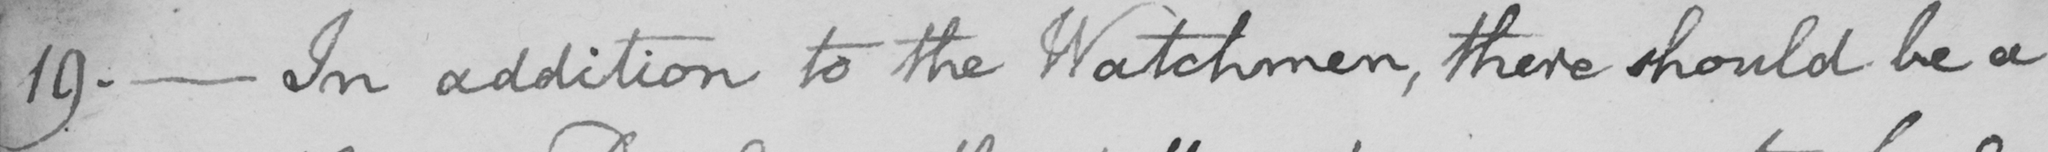What text is written in this handwritten line? 19 .  _  In addition to the Watchmen , there should be a 